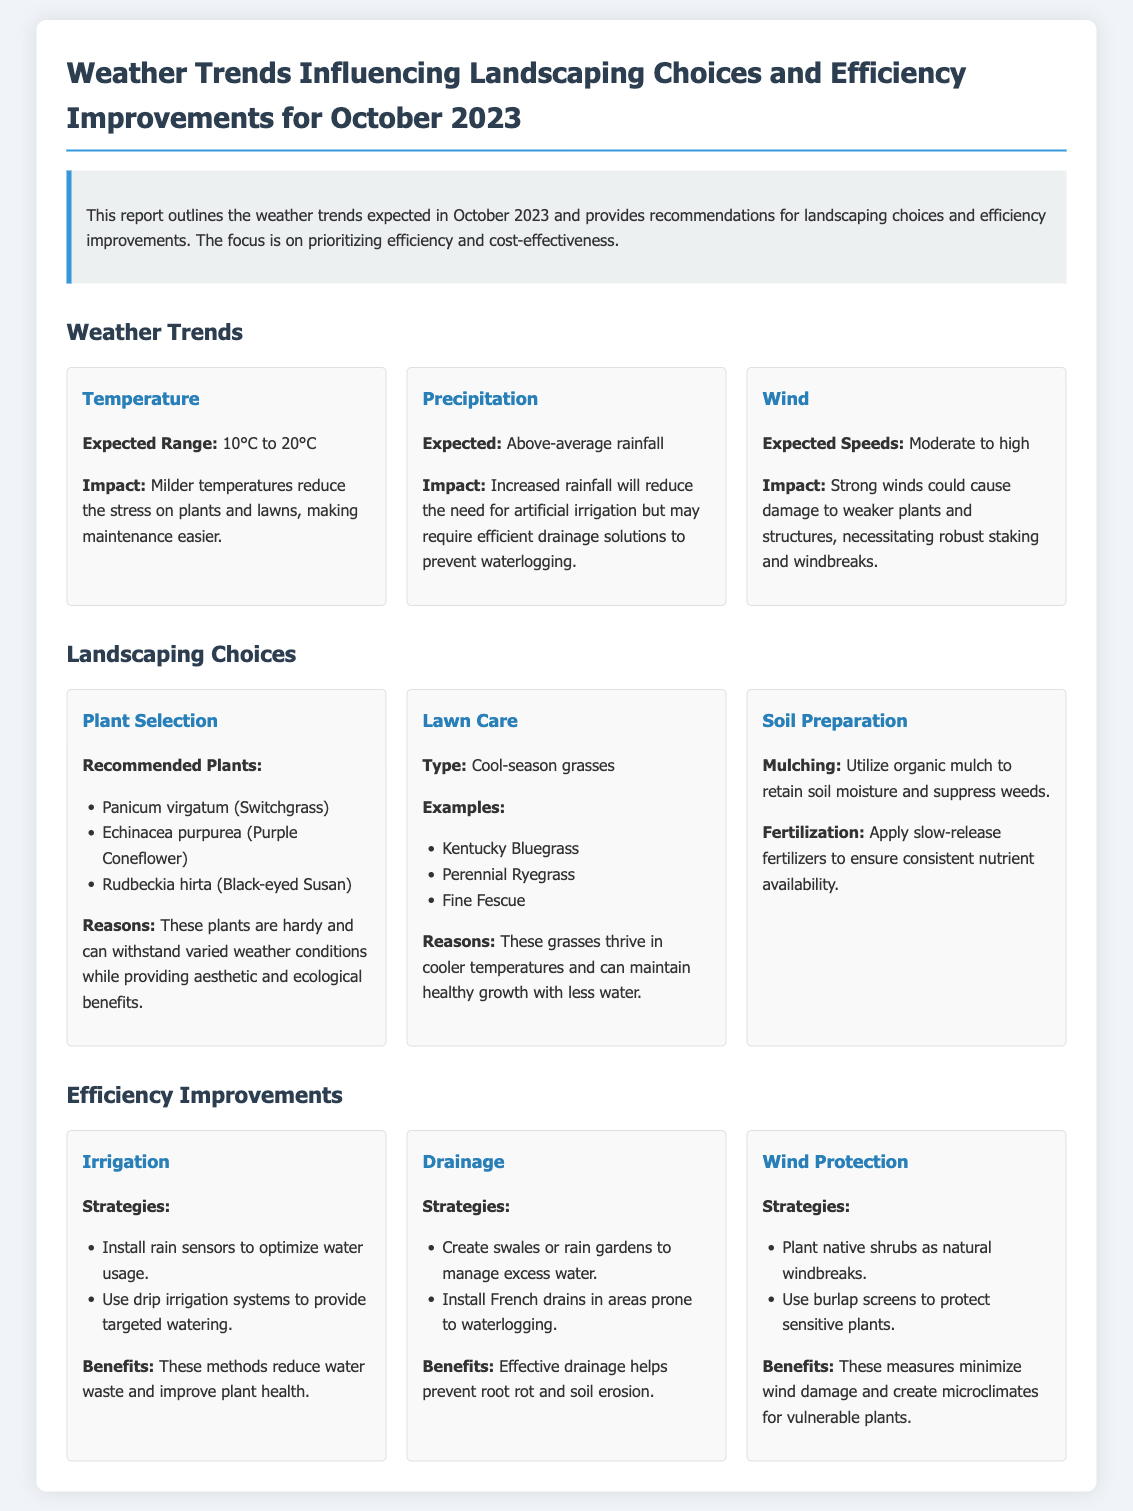what is the expected temperature range for October 2023? The expected temperature range is provided in the document, which states that it is 10°C to 20°C.
Answer: 10°C to 20°C what rainfall condition is expected in October 2023? The document mentions that there will be above-average rainfall expected for this month.
Answer: Above-average rainfall what is one of the recommended plants for landscaping? The document lists recommended plants, including Panicum virgatum (Switchgrass).
Answer: Panicum virgatum which type of grasses is suggested for lawn care? The document specifies that cool-season grasses are recommended for lawn care.
Answer: Cool-season grasses what strategy is recommended for irrigation improvements? The document provides strategies, including the installation of rain sensors to optimize water usage.
Answer: Install rain sensors what impact does moderate to high wind have on landscaping? The document explains that strong winds could cause damage to weaker plants and structures.
Answer: Damage to weaker plants why is organic mulch recommended for soil preparation? The document states that mulching is used to retain soil moisture and suppress weeds.
Answer: Retain soil moisture and suppress weeds what is a benefit of using drip irrigation systems? The document highlights that drip irrigation systems reduce water waste and improve plant health.
Answer: Reduce water waste what landscaping choice can help manage excess water? The document recommends creating swales or rain gardens for excess water management.
Answer: Create swales or rain gardens 